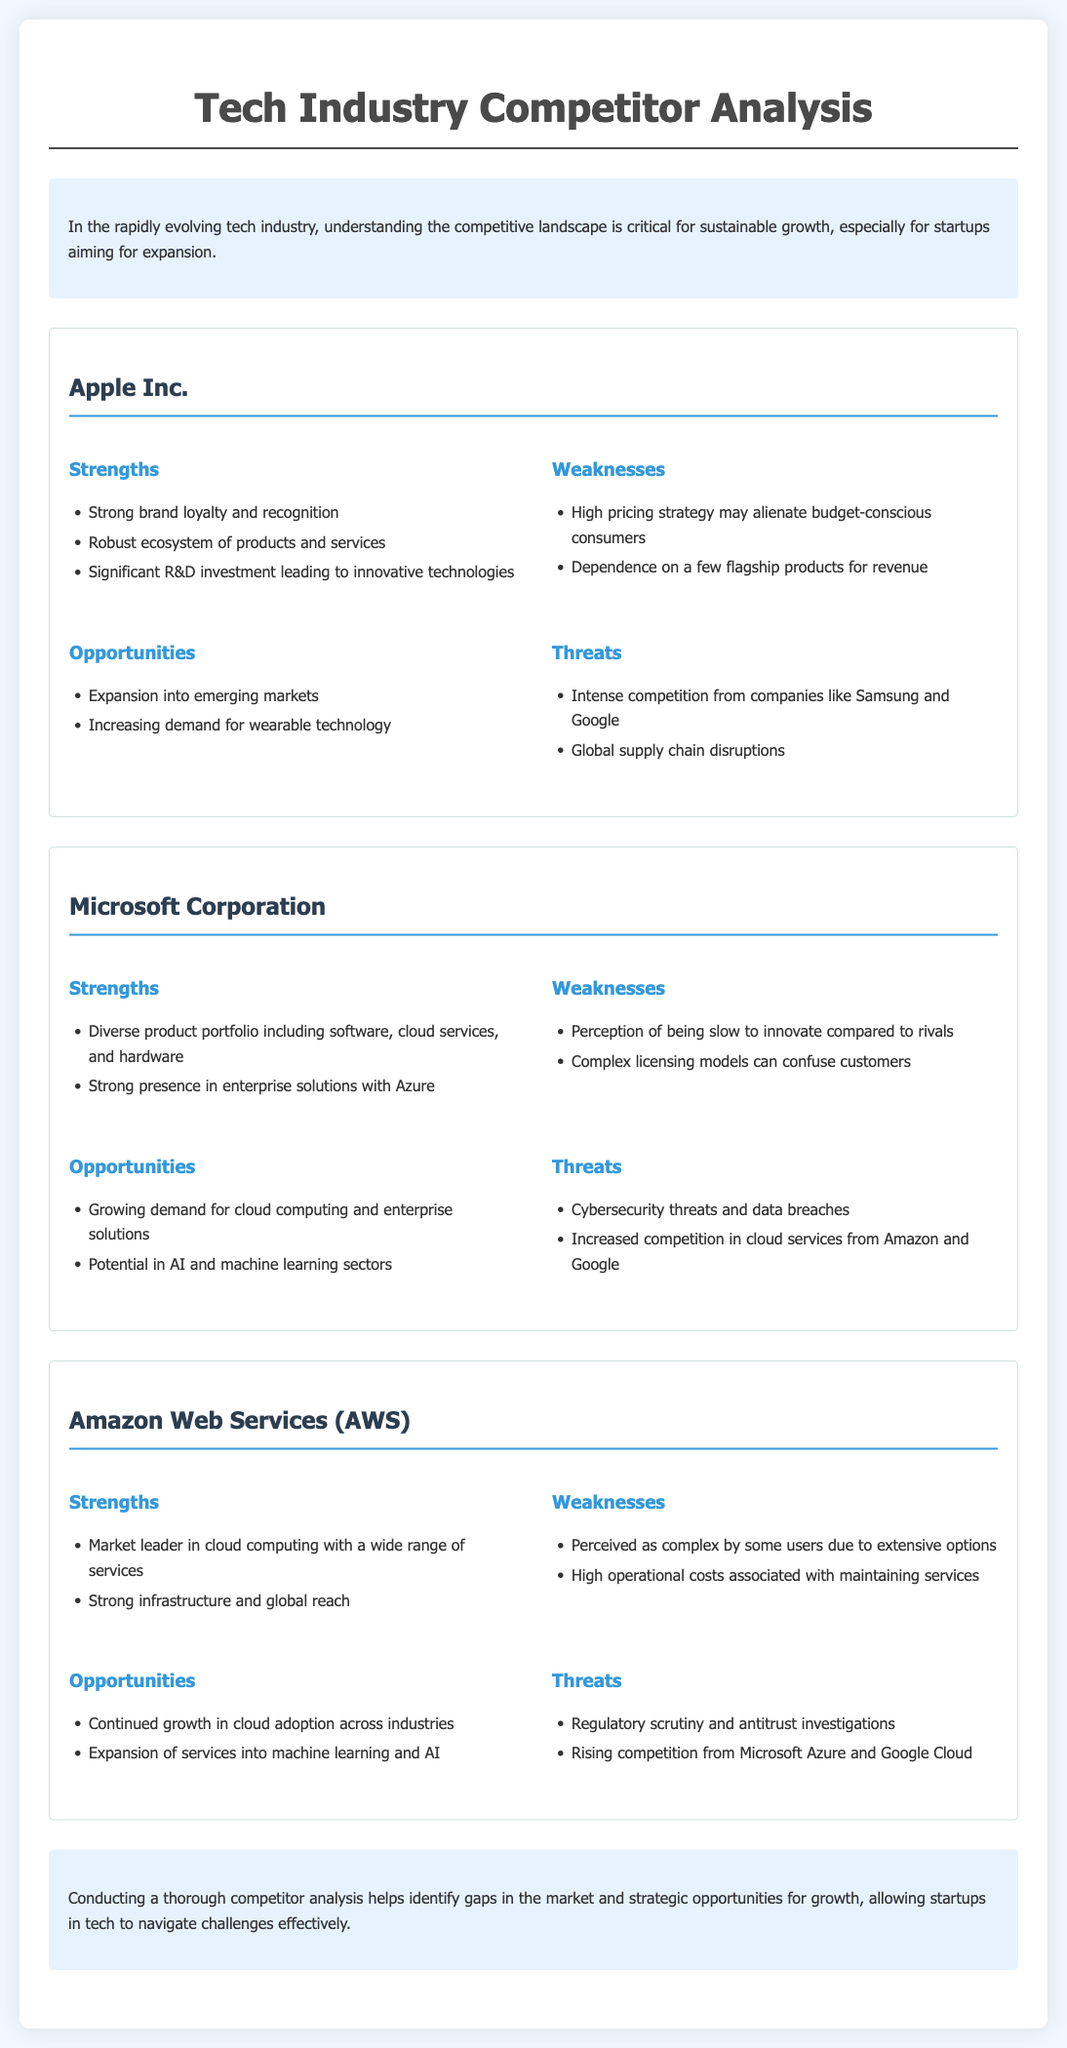what are the strengths of Apple Inc.? The strengths of Apple Inc. include brand loyalty, a robust ecosystem, and significant R&D investment.
Answer: Strong brand loyalty and recognition, Robust ecosystem of products and services, Significant R&D investment leading to innovative technologies what weaknesses does Microsoft Corporation have? The weaknesses of Microsoft Corporation are its perception of innovation and complex licensing models.
Answer: Perception of being slow to innovate compared to rivals, Complex licensing models can confuse customers what opportunities are available for Amazon Web Services? The opportunities for Amazon Web Services include growth in cloud adoption and expansion into AI services.
Answer: Continued growth in cloud adoption across industries, Expansion of services into machine learning and AI how many competitors are analyzed in the document? The document lists three competitors being analyzed: Apple Inc., Microsoft Corporation, and Amazon Web Services.
Answer: Three what is the main conclusion of the document? The conclusion indicates the importance of conducting competitor analysis for identifying market gaps and strategic opportunities.
Answer: Conducting a thorough competitor analysis helps identify gaps in the market and strategic opportunities for growth what threat is mentioned for Apple Inc.? The threat for Apple Inc. highlighted in the document is intense competition and supply chain disruptions.
Answer: Intense competition from companies like Samsung and Google, Global supply chain disruptions which company has a strong presence in enterprise solutions? Microsoft Corporation has a strong presence in enterprise solutions mainly due to its Azure platform.
Answer: Microsoft Corporation what are the weaknesses of Amazon Web Services? The weaknesses of Amazon Web Services include perceived complexity and high operational costs.
Answer: Perceived as complex by some users due to extensive options, High operational costs associated with maintaining services 